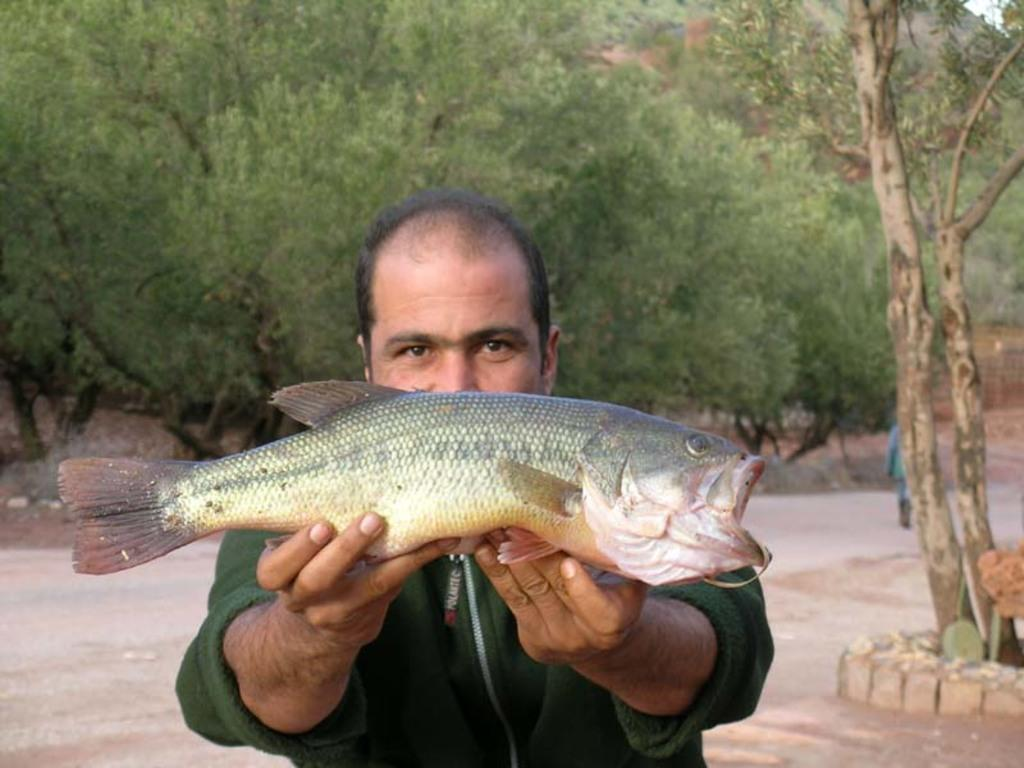Who is present in the image? There is a man in the image. What is the man holding in the image? The man is holding a fish. What can be seen in the background of the image? There are trees in the background of the image. What type of apple is being used as a decoration on the dinner table in the image? There is no apple or dinner table present in the image; it features a man holding a fish with trees in the background. 